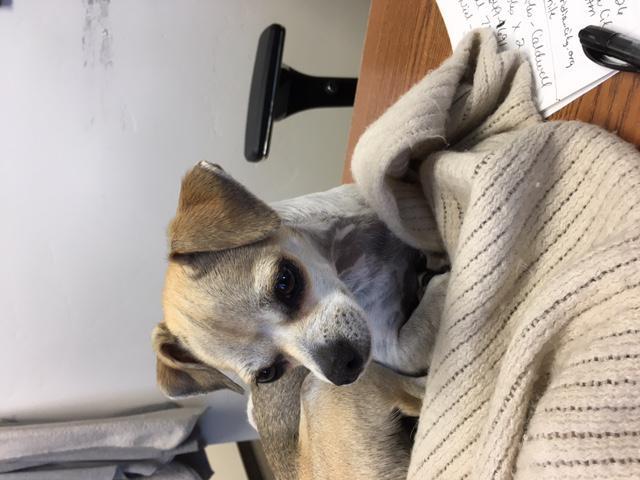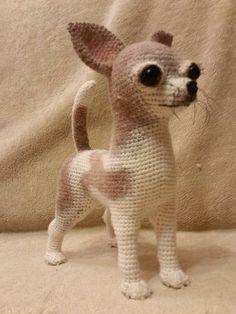The first image is the image on the left, the second image is the image on the right. For the images displayed, is the sentence "At least two dogs are snuggling together." factually correct? Answer yes or no. No. The first image is the image on the left, the second image is the image on the right. Evaluate the accuracy of this statement regarding the images: "All of the dogs are real and some are dressed like humans.". Is it true? Answer yes or no. No. 